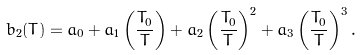Convert formula to latex. <formula><loc_0><loc_0><loc_500><loc_500>b _ { 2 } ( T ) = a _ { 0 } + a _ { 1 } \left ( \frac { T _ { 0 } } { T } \right ) + a _ { 2 } \left ( \frac { T _ { 0 } } { T } \right ) ^ { 2 } + a _ { 3 } \left ( \frac { T _ { 0 } } { T } \right ) ^ { 3 } . \\</formula> 